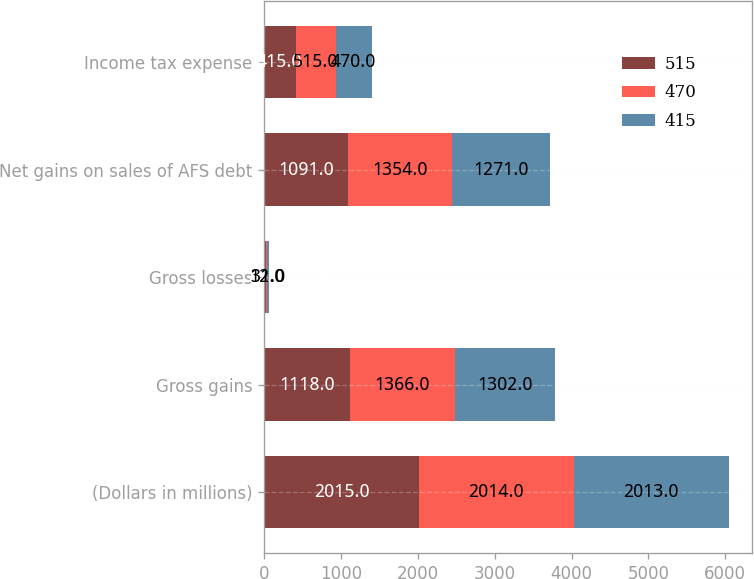Convert chart to OTSL. <chart><loc_0><loc_0><loc_500><loc_500><stacked_bar_chart><ecel><fcel>(Dollars in millions)<fcel>Gross gains<fcel>Gross losses<fcel>Net gains on sales of AFS debt<fcel>Income tax expense<nl><fcel>515<fcel>2015<fcel>1118<fcel>27<fcel>1091<fcel>415<nl><fcel>470<fcel>2014<fcel>1366<fcel>12<fcel>1354<fcel>515<nl><fcel>415<fcel>2013<fcel>1302<fcel>31<fcel>1271<fcel>470<nl></chart> 